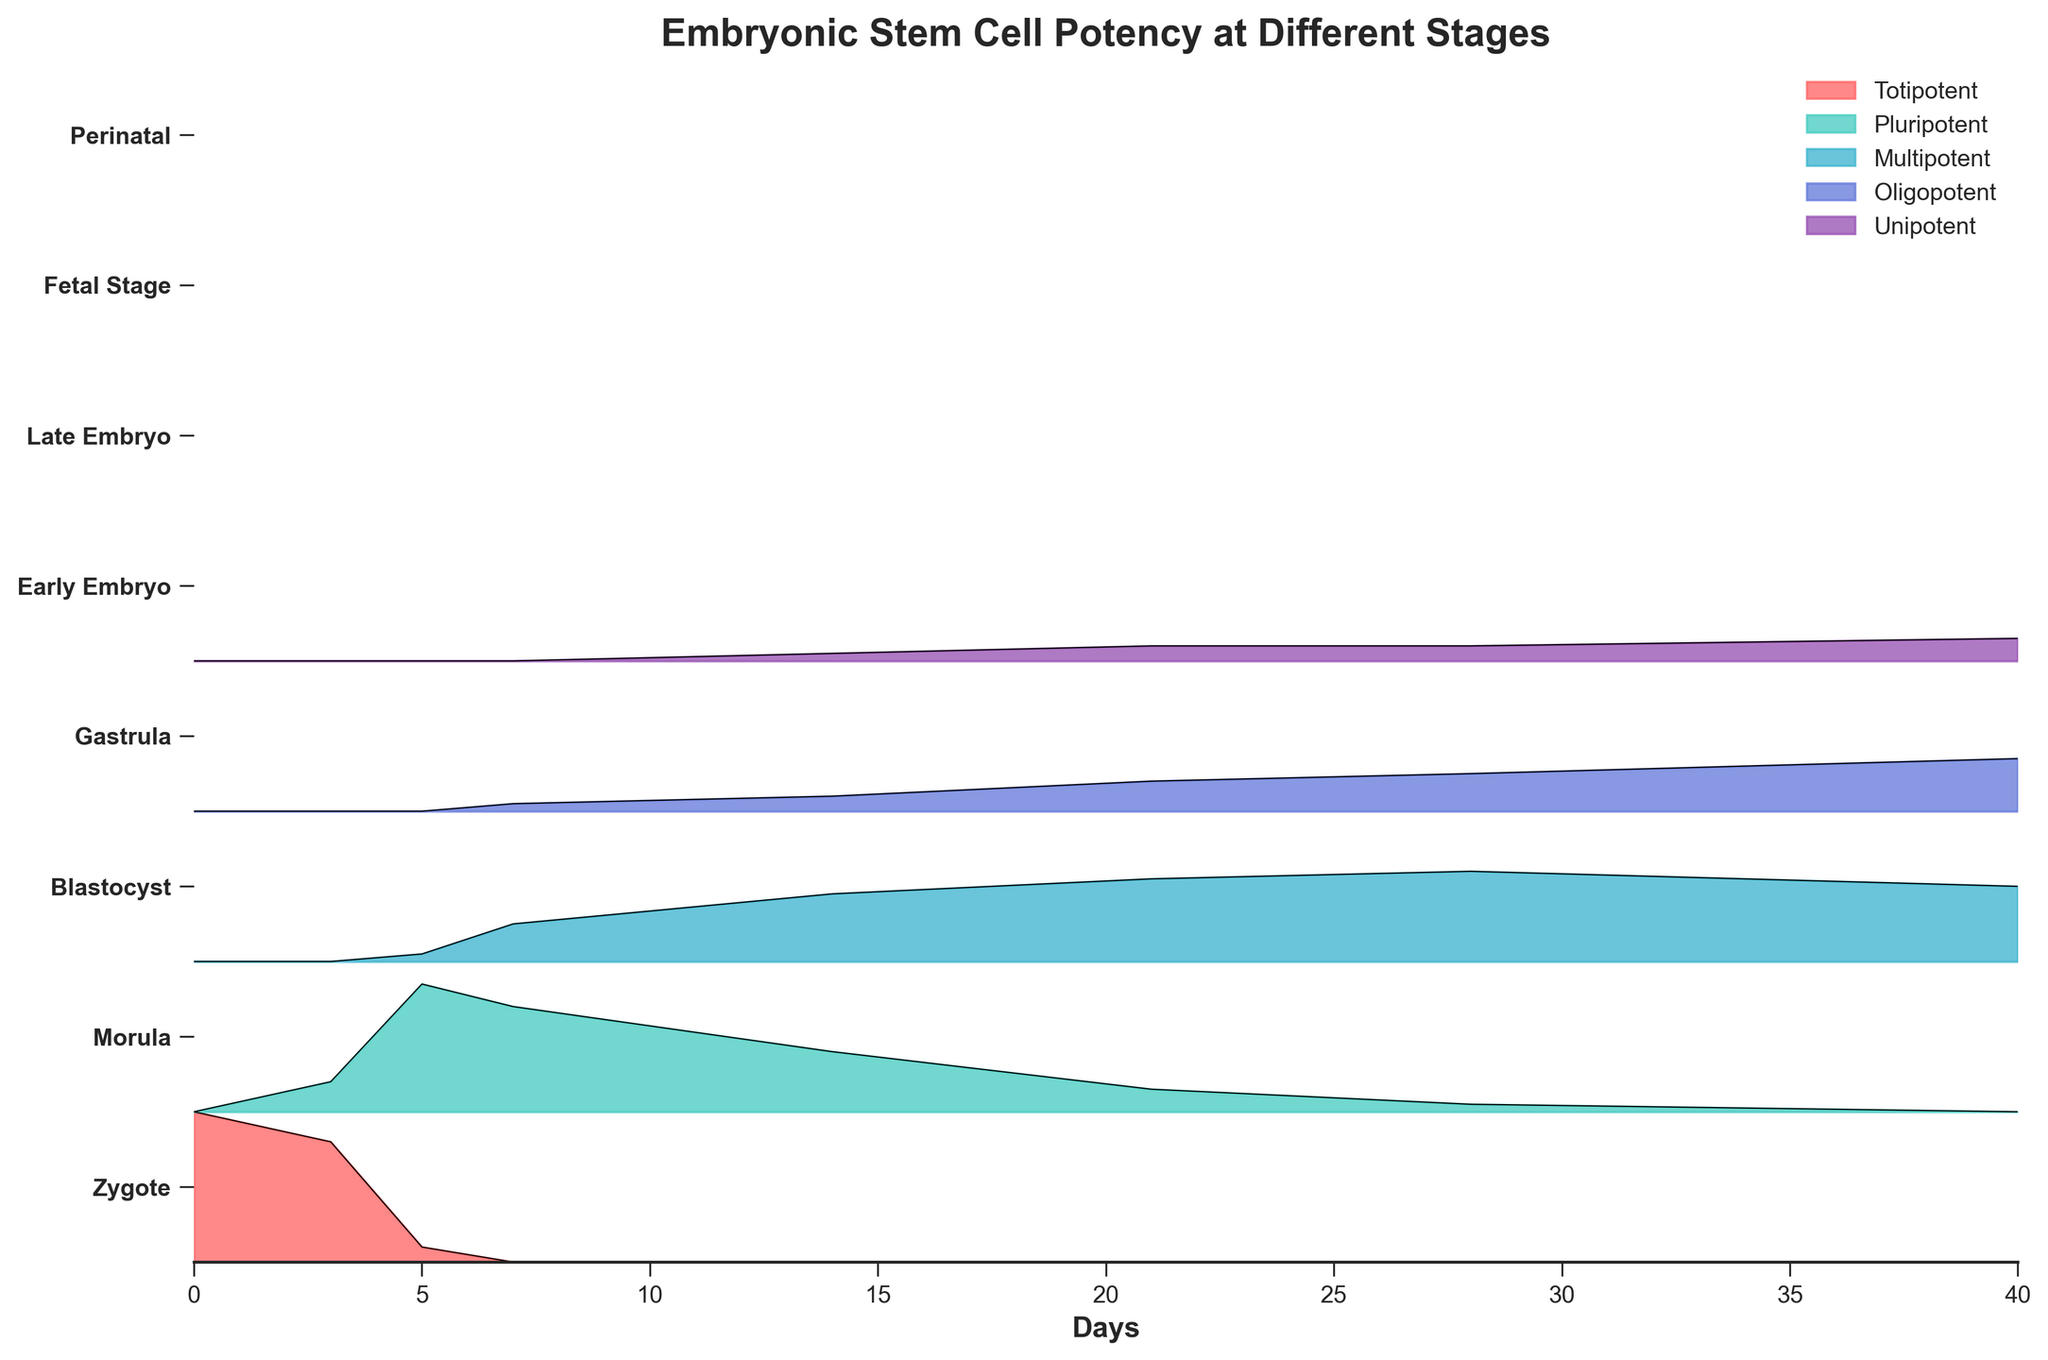what is the title of the figure? The title is usually found at the top of the plot and provides a brief description of what the figure is about. For this figure, the title is "Embryonic Stem Cell Potency at Different Stages."
Answer: Embryonic Stem Cell Potency at Different Stages what is on the x-axis of the figure? The x-axis typically represents the independent variable being measured or compared. In this figure, the x-axis represents the "Days," which indicate the developmental stages over time.
Answer: Days which category has the highest representation in the Morula stage? At the Morula stage (Day 3), look for the category with the largest portion of the section. The "Totipotent" category has the highest representation.
Answer: Totipotent which category first appears at the Blastocyst stage and what is its percentage? The "Multipotent" category first appears at the Blastocyst stage (Day 5). From the figure, it occupies 5% of the section.
Answer: Multipotent, 5% how does the representation of Pluripotent cells change from the Zygote to the Perinatal stage? The Pluripotent category starts at 0% in the Zygote stage, reaches a peak at the Blastocyst with 85%, gradually decreases, and finally drops to 0% by the Perinatal stage.
Answer: Increases to 85%, then decreases to 0% which category has the highest representation at the Perinatal stage? At the Perinatal stage (Day 40), look for the category covering the largest area. The "Oligopotent" category has the highest representation with 35%.
Answer: Oligopotent how does the proportion of Totipotent cells change from the Zygote to the Fetal Stage? Totipotent cells start at 100% in the Zygote (Day 0) and drop to 0% by the Fetal Stage (Day 28).
Answer: Decreases from 100% to 0% which category increases the most between the Early Embryo and Late Embryo stages? Compare the changes in each category between the Early Embryo (Day 14) and Late Embryo (Day 21) stages. The "Multipotent" category increases the most from 45% to 55%.
Answer: Multipotent compare the proportion of Oligopotent cells at the Early Embryo and Perinatal stages? At the Early Embryo stage, Oligopotent cells make up 10%, while at the Perinatal stage, they make up 35%.
Answer: Higher at the Perinatal stage, 35% vs. 10% what is the trend of the Unipotent category from the Gastrula stage to the Late Embryo stage? The Unipotent category first appears at 0% in the Gastrula stage (Day 7), increases to 5% by the Early Embryo stage (Day 14), and reaches 10% by the Late Embryo stage (Day 21).
Answer: Increases from 0% to 10% 